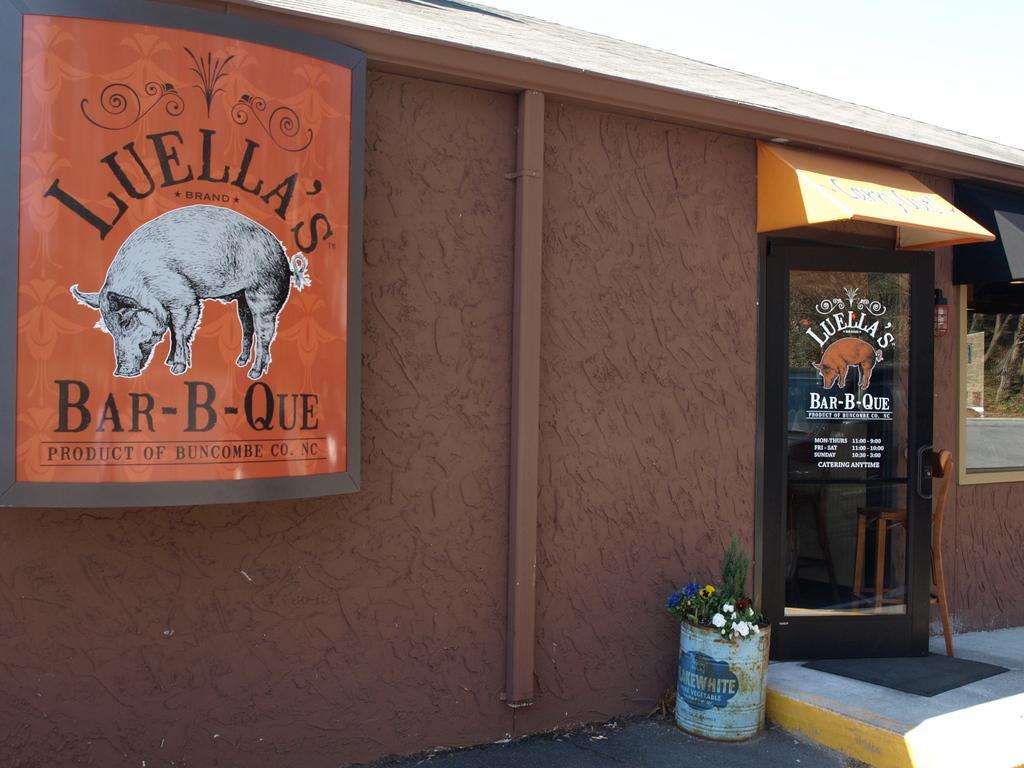Can you describe this image briefly? It seems like a house in the image. There is a board attached to the wall and there is a door on the right side of this image. There are flower plants at the bottom of this image. 